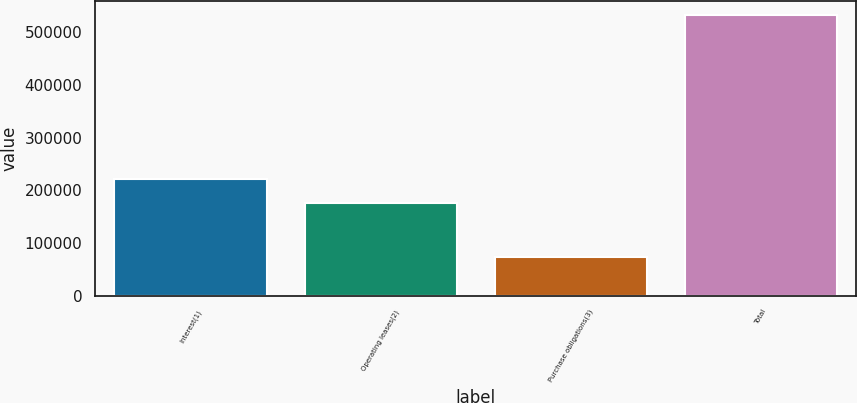<chart> <loc_0><loc_0><loc_500><loc_500><bar_chart><fcel>Interest(1)<fcel>Operating leases(2)<fcel>Purchase obligations(3)<fcel>Total<nl><fcel>222259<fcel>176318<fcel>74210<fcel>533623<nl></chart> 